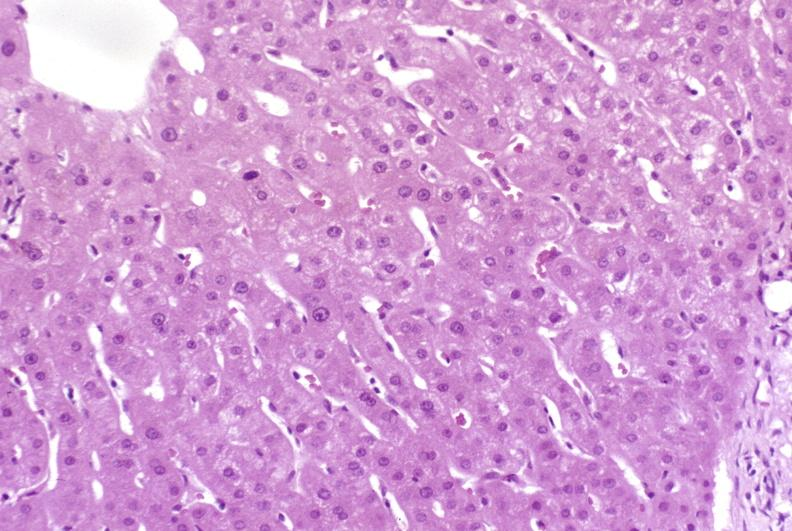what does this image show?
Answer the question using a single word or phrase. Resolving acute rejection 